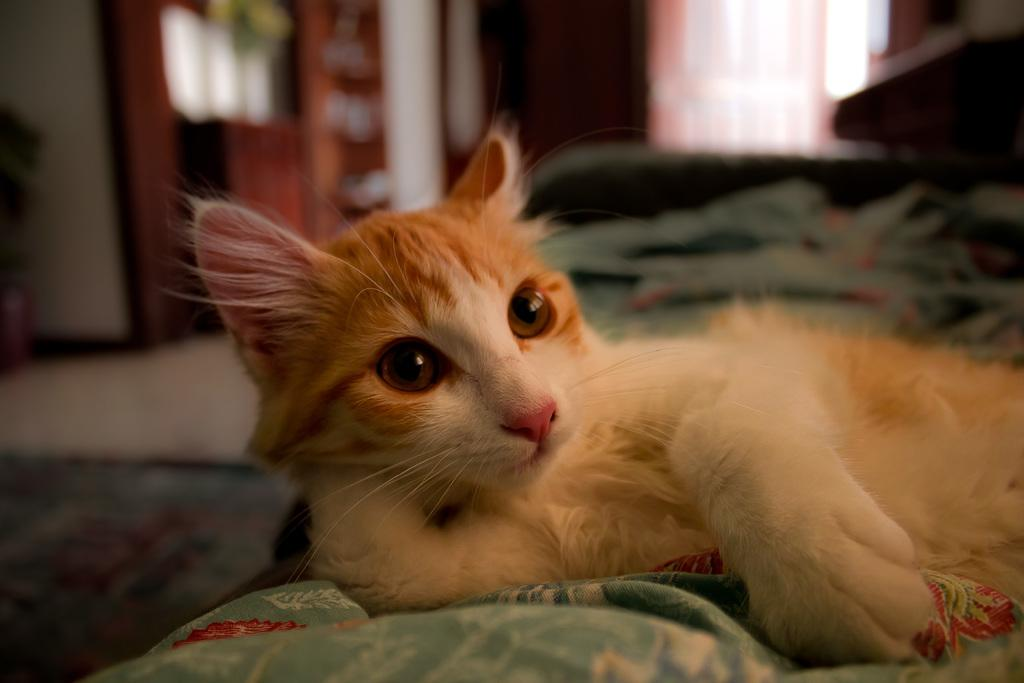What type of animal is in the image? There is a cat in the image. Can you describe the appearance of the cat? The cat is brown and white in color. What is the cat doing in the image? The cat is laying down on a bed. What color is the bed sheet on the bed? The bed sheet on the bed is green. What other objects can be seen in the background of the image? There are other objects in the background of the image, but their specific details are not mentioned in the provided facts. What time is the spy meeting the cat in the image? There is no mention of a spy or a meeting in the image, so it is not possible to determine the time of any such event. 